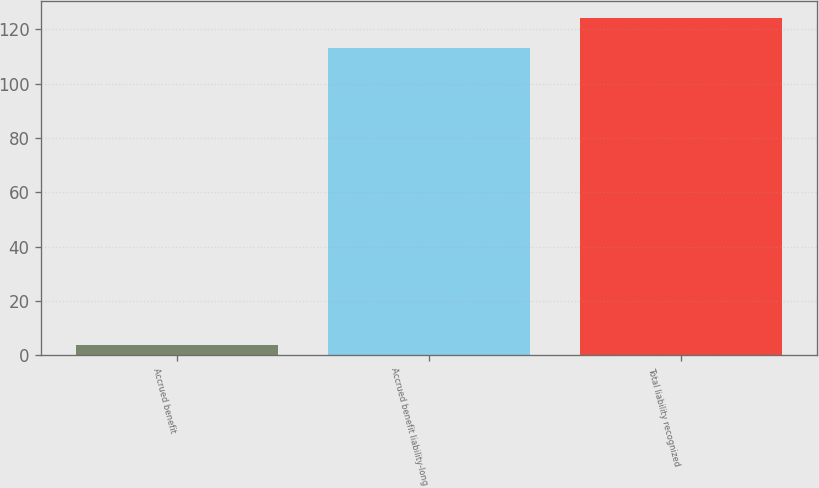Convert chart. <chart><loc_0><loc_0><loc_500><loc_500><bar_chart><fcel>Accrued benefit<fcel>Accrued benefit liability-long<fcel>Total liability recognized<nl><fcel>4<fcel>113<fcel>124.3<nl></chart> 